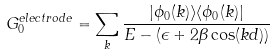<formula> <loc_0><loc_0><loc_500><loc_500>G _ { 0 } ^ { e l e c t r o d e } = \sum _ { k } \frac { | \phi _ { 0 } ( k ) \rangle \langle \phi _ { 0 } ( k ) | } { E - ( \epsilon + 2 \beta \cos ( k d ) ) }</formula> 